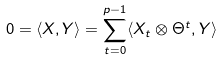Convert formula to latex. <formula><loc_0><loc_0><loc_500><loc_500>0 = \langle X , Y \rangle = \sum _ { t = 0 } ^ { p - 1 } \langle X _ { t } \otimes \Theta ^ { t } , Y \rangle</formula> 